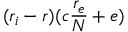Convert formula to latex. <formula><loc_0><loc_0><loc_500><loc_500>( r _ { i } - r ) ( c \frac { r _ { e } } { N } + e )</formula> 